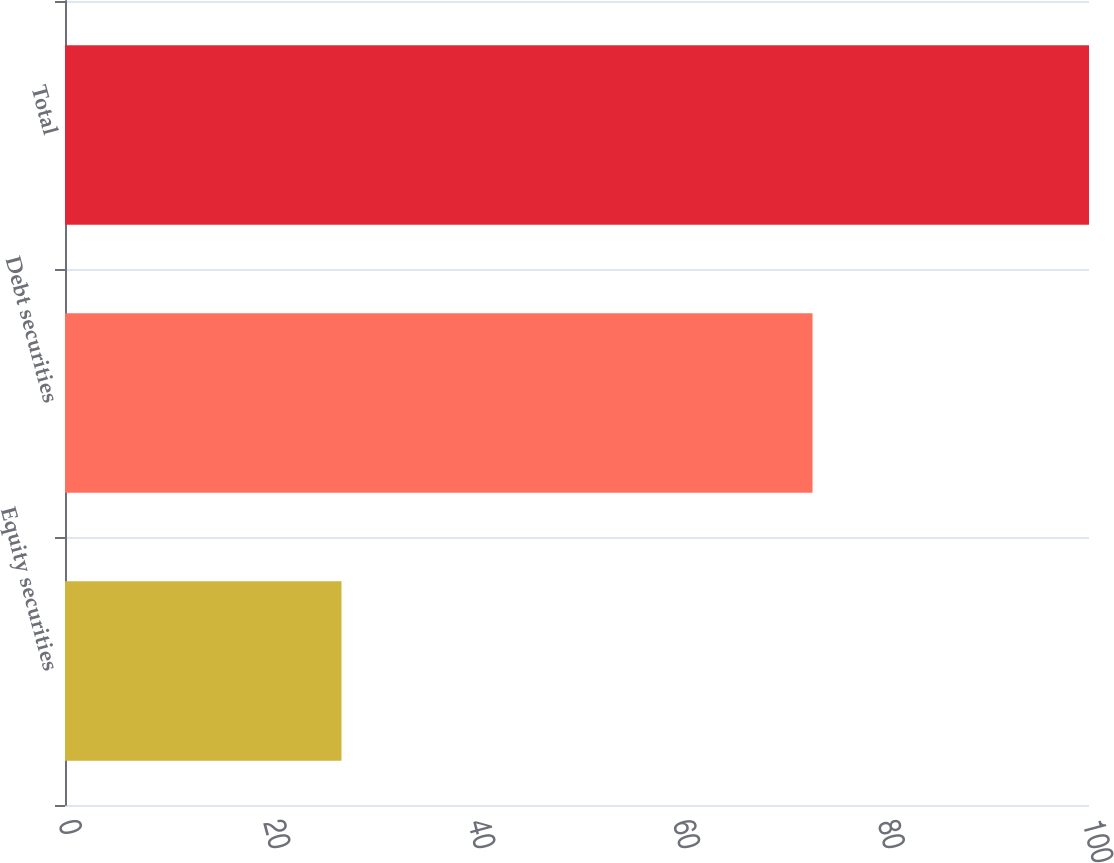Convert chart to OTSL. <chart><loc_0><loc_0><loc_500><loc_500><bar_chart><fcel>Equity securities<fcel>Debt securities<fcel>Total<nl><fcel>27<fcel>73<fcel>100<nl></chart> 